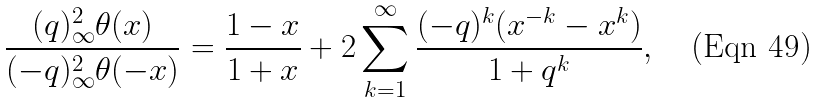Convert formula to latex. <formula><loc_0><loc_0><loc_500><loc_500>\frac { ( q ) _ { \infty } ^ { 2 } \theta ( x ) } { ( - q ) _ { \infty } ^ { 2 } \theta ( - x ) } = \frac { 1 - x } { 1 + x } + 2 \sum _ { k = 1 } ^ { \infty } \frac { ( - q ) ^ { k } ( x ^ { - k } - x ^ { k } ) } { 1 + q ^ { k } } ,</formula> 